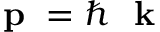<formula> <loc_0><loc_0><loc_500><loc_500>p = \hbar { k }</formula> 